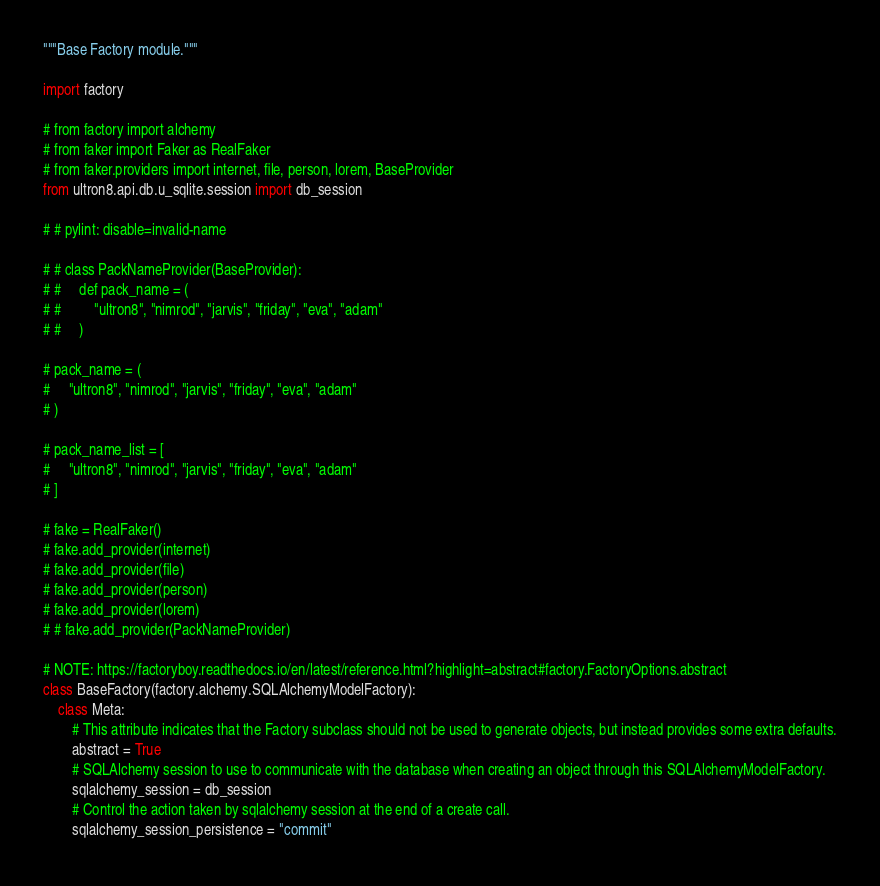<code> <loc_0><loc_0><loc_500><loc_500><_Python_>"""Base Factory module."""

import factory

# from factory import alchemy
# from faker import Faker as RealFaker
# from faker.providers import internet, file, person, lorem, BaseProvider
from ultron8.api.db.u_sqlite.session import db_session

# # pylint: disable=invalid-name

# # class PackNameProvider(BaseProvider):
# #     def pack_name = (
# #         "ultron8", "nimrod", "jarvis", "friday", "eva", "adam"
# #     )

# pack_name = (
#     "ultron8", "nimrod", "jarvis", "friday", "eva", "adam"
# )

# pack_name_list = [
#     "ultron8", "nimrod", "jarvis", "friday", "eva", "adam"
# ]

# fake = RealFaker()
# fake.add_provider(internet)
# fake.add_provider(file)
# fake.add_provider(person)
# fake.add_provider(lorem)
# # fake.add_provider(PackNameProvider)

# NOTE: https://factoryboy.readthedocs.io/en/latest/reference.html?highlight=abstract#factory.FactoryOptions.abstract
class BaseFactory(factory.alchemy.SQLAlchemyModelFactory):
    class Meta:
        # This attribute indicates that the Factory subclass should not be used to generate objects, but instead provides some extra defaults.
        abstract = True
        # SQLAlchemy session to use to communicate with the database when creating an object through this SQLAlchemyModelFactory.
        sqlalchemy_session = db_session
        # Control the action taken by sqlalchemy session at the end of a create call.
        sqlalchemy_session_persistence = "commit"
</code> 